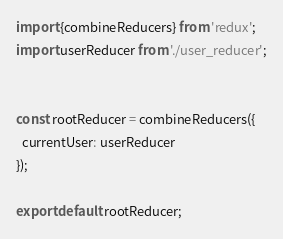<code> <loc_0><loc_0><loc_500><loc_500><_JavaScript_>import {combineReducers} from 'redux';
import userReducer from './user_reducer';


const rootReducer = combineReducers({
  currentUser: userReducer
});

export default rootReducer;
</code> 